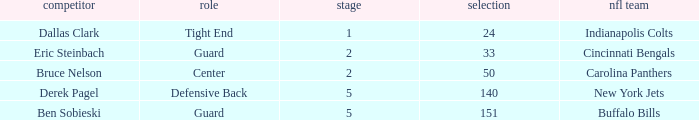Can you parse all the data within this table? {'header': ['competitor', 'role', 'stage', 'selection', 'nfl team'], 'rows': [['Dallas Clark', 'Tight End', '1', '24', 'Indianapolis Colts'], ['Eric Steinbach', 'Guard', '2', '33', 'Cincinnati Bengals'], ['Bruce Nelson', 'Center', '2', '50', 'Carolina Panthers'], ['Derek Pagel', 'Defensive Back', '5', '140', 'New York Jets'], ['Ben Sobieski', 'Guard', '5', '151', 'Buffalo Bills']]} During which round was a Hawkeyes player selected for the defensive back position? 5.0. 